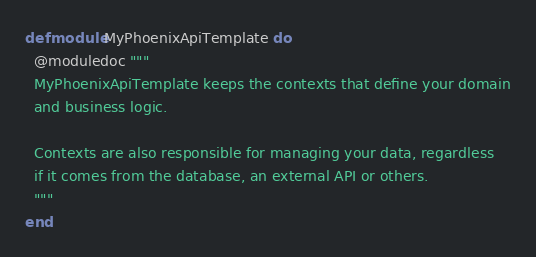<code> <loc_0><loc_0><loc_500><loc_500><_Elixir_>defmodule MyPhoenixApiTemplate do
  @moduledoc """
  MyPhoenixApiTemplate keeps the contexts that define your domain
  and business logic.

  Contexts are also responsible for managing your data, regardless
  if it comes from the database, an external API or others.
  """
end
</code> 